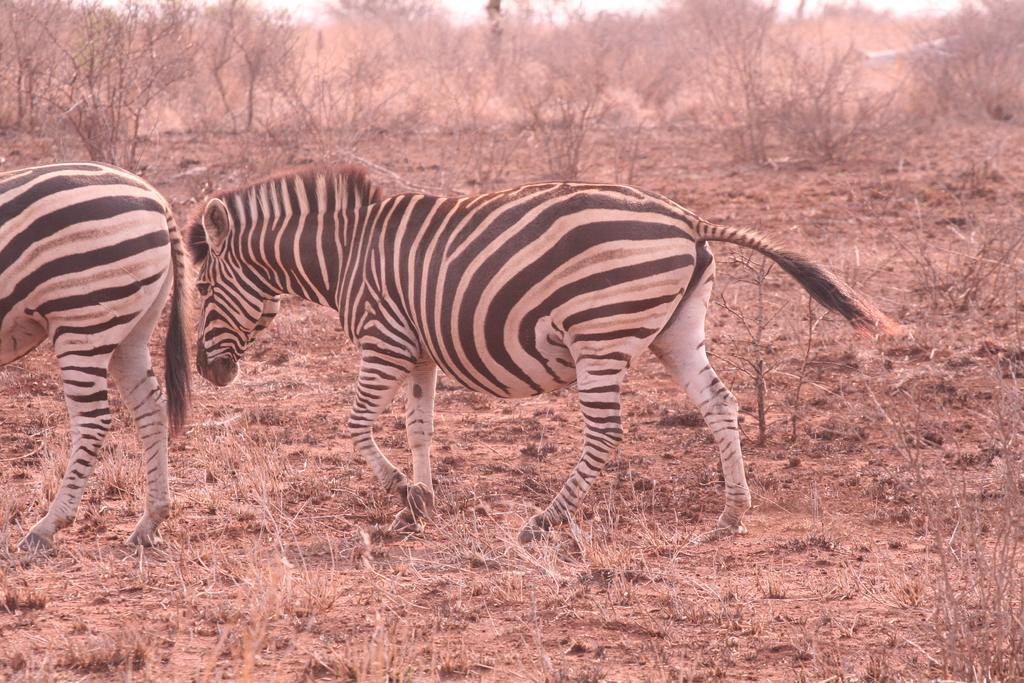What animals can be seen in the image? There are zebras in the image. What are the zebras doing in the image? The zebras are walking on the ground. What can be seen in the background of the image? There are trees, plants, and the sky visible in the background of the image. What type of dog can be seen in the frame with the zebras? There is no dog present in the image; it only features zebras walking on the ground. 